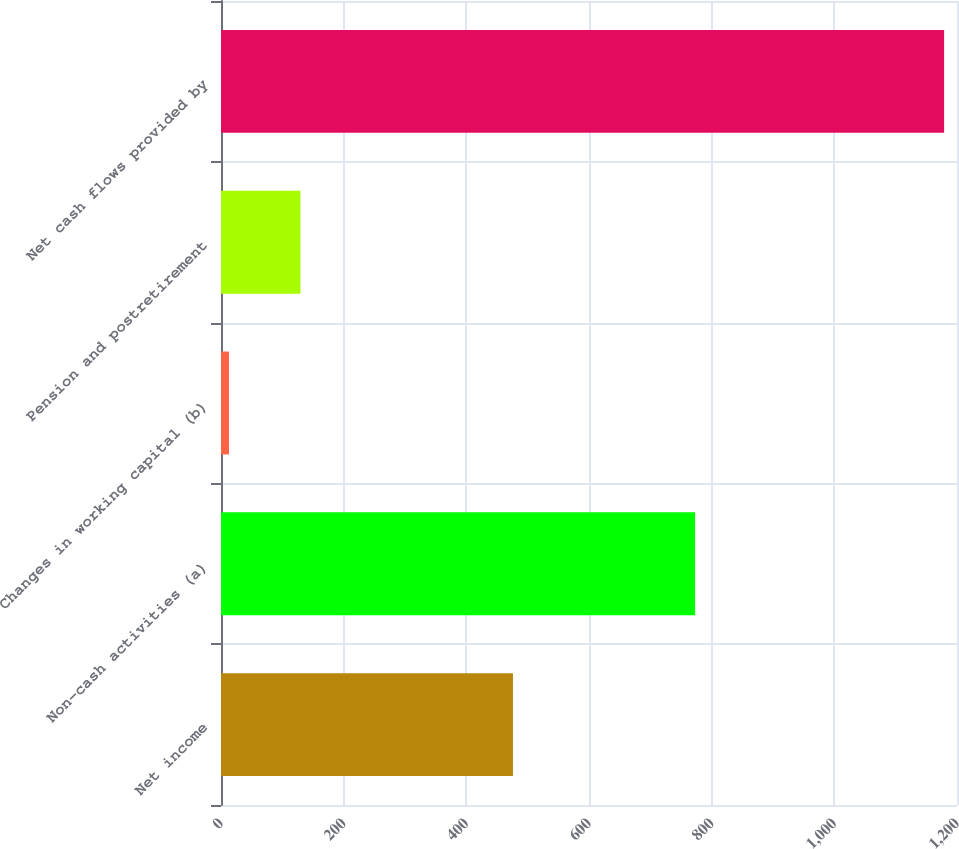<chart> <loc_0><loc_0><loc_500><loc_500><bar_chart><fcel>Net income<fcel>Non-cash activities (a)<fcel>Changes in working capital (b)<fcel>Pension and postretirement<fcel>Net cash flows provided by<nl><fcel>476<fcel>773<fcel>13<fcel>129.6<fcel>1179<nl></chart> 